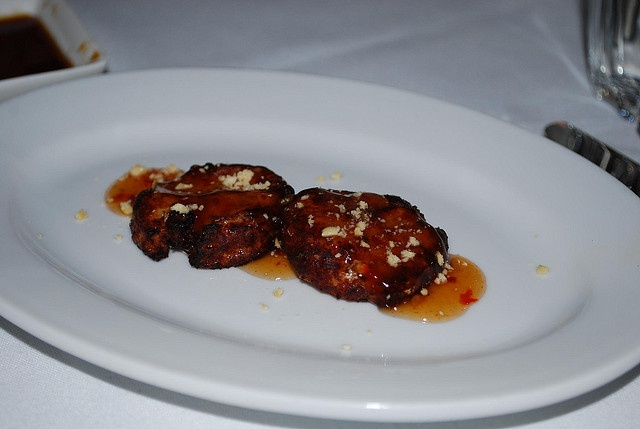Describe the objects in this image and their specific colors. I can see dining table in darkgray, gray, and black tones, bowl in gray and black tones, cup in gray and black tones, and knife in gray and black tones in this image. 